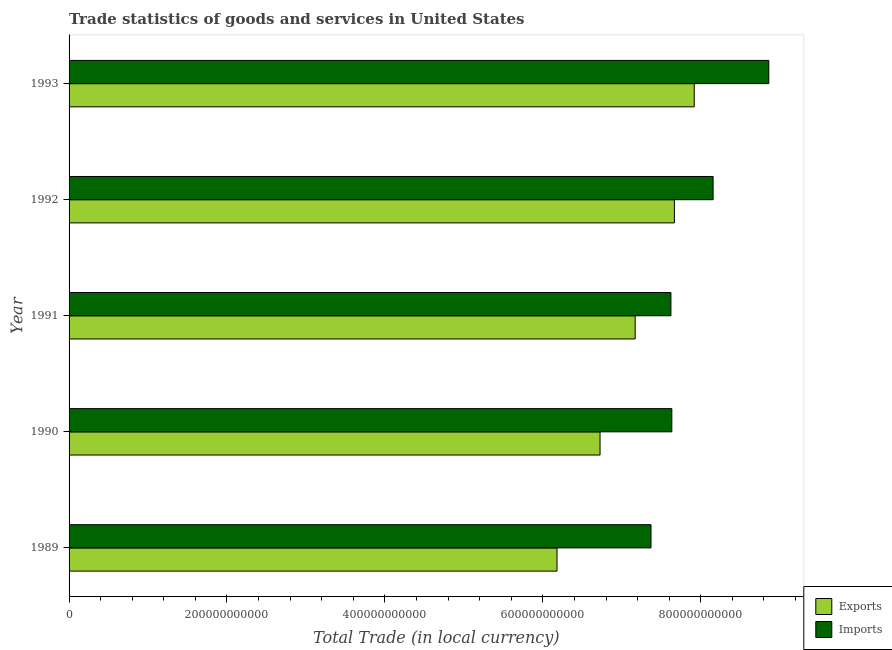How many different coloured bars are there?
Your answer should be very brief. 2. How many bars are there on the 1st tick from the top?
Make the answer very short. 2. How many bars are there on the 5th tick from the bottom?
Offer a terse response. 2. What is the export of goods and services in 1993?
Your answer should be very brief. 7.92e+11. Across all years, what is the maximum imports of goods and services?
Give a very brief answer. 8.86e+11. Across all years, what is the minimum export of goods and services?
Offer a very short reply. 6.18e+11. In which year was the export of goods and services maximum?
Make the answer very short. 1993. What is the total imports of goods and services in the graph?
Provide a short and direct response. 3.96e+12. What is the difference between the imports of goods and services in 1989 and that in 1990?
Ensure brevity in your answer.  -2.64e+1. What is the difference between the export of goods and services in 1989 and the imports of goods and services in 1993?
Ensure brevity in your answer.  -2.68e+11. What is the average export of goods and services per year?
Your answer should be very brief. 7.13e+11. In the year 1989, what is the difference between the export of goods and services and imports of goods and services?
Ensure brevity in your answer.  -1.19e+11. In how many years, is the imports of goods and services greater than 840000000000 LCU?
Offer a very short reply. 1. What is the ratio of the imports of goods and services in 1989 to that in 1991?
Offer a terse response. 0.97. What is the difference between the highest and the second highest imports of goods and services?
Your response must be concise. 7.05e+1. What is the difference between the highest and the lowest imports of goods and services?
Give a very brief answer. 1.49e+11. In how many years, is the export of goods and services greater than the average export of goods and services taken over all years?
Provide a short and direct response. 3. Is the sum of the export of goods and services in 1990 and 1993 greater than the maximum imports of goods and services across all years?
Offer a very short reply. Yes. What does the 1st bar from the top in 1992 represents?
Offer a terse response. Imports. What does the 2nd bar from the bottom in 1989 represents?
Provide a short and direct response. Imports. What is the difference between two consecutive major ticks on the X-axis?
Your response must be concise. 2.00e+11. Where does the legend appear in the graph?
Provide a short and direct response. Bottom right. How many legend labels are there?
Your answer should be very brief. 2. What is the title of the graph?
Offer a terse response. Trade statistics of goods and services in United States. Does "Age 65(male)" appear as one of the legend labels in the graph?
Your answer should be compact. No. What is the label or title of the X-axis?
Offer a terse response. Total Trade (in local currency). What is the Total Trade (in local currency) of Exports in 1989?
Ensure brevity in your answer.  6.18e+11. What is the Total Trade (in local currency) in Imports in 1989?
Offer a terse response. 7.37e+11. What is the Total Trade (in local currency) in Exports in 1990?
Provide a succinct answer. 6.72e+11. What is the Total Trade (in local currency) of Imports in 1990?
Your answer should be very brief. 7.63e+11. What is the Total Trade (in local currency) in Exports in 1991?
Keep it short and to the point. 7.17e+11. What is the Total Trade (in local currency) in Imports in 1991?
Make the answer very short. 7.62e+11. What is the Total Trade (in local currency) of Exports in 1992?
Offer a terse response. 7.67e+11. What is the Total Trade (in local currency) in Imports in 1992?
Offer a terse response. 8.16e+11. What is the Total Trade (in local currency) in Exports in 1993?
Offer a terse response. 7.92e+11. What is the Total Trade (in local currency) of Imports in 1993?
Ensure brevity in your answer.  8.86e+11. Across all years, what is the maximum Total Trade (in local currency) in Exports?
Ensure brevity in your answer.  7.92e+11. Across all years, what is the maximum Total Trade (in local currency) in Imports?
Provide a succinct answer. 8.86e+11. Across all years, what is the minimum Total Trade (in local currency) of Exports?
Provide a succinct answer. 6.18e+11. Across all years, what is the minimum Total Trade (in local currency) in Imports?
Offer a terse response. 7.37e+11. What is the total Total Trade (in local currency) in Exports in the graph?
Your response must be concise. 3.57e+12. What is the total Total Trade (in local currency) of Imports in the graph?
Provide a short and direct response. 3.96e+12. What is the difference between the Total Trade (in local currency) of Exports in 1989 and that in 1990?
Offer a very short reply. -5.45e+1. What is the difference between the Total Trade (in local currency) in Imports in 1989 and that in 1990?
Ensure brevity in your answer.  -2.64e+1. What is the difference between the Total Trade (in local currency) in Exports in 1989 and that in 1991?
Your answer should be compact. -9.90e+1. What is the difference between the Total Trade (in local currency) of Imports in 1989 and that in 1991?
Offer a very short reply. -2.52e+1. What is the difference between the Total Trade (in local currency) of Exports in 1989 and that in 1992?
Make the answer very short. -1.49e+11. What is the difference between the Total Trade (in local currency) of Imports in 1989 and that in 1992?
Offer a terse response. -7.87e+1. What is the difference between the Total Trade (in local currency) of Exports in 1989 and that in 1993?
Keep it short and to the point. -1.74e+11. What is the difference between the Total Trade (in local currency) in Imports in 1989 and that in 1993?
Make the answer very short. -1.49e+11. What is the difference between the Total Trade (in local currency) of Exports in 1990 and that in 1991?
Keep it short and to the point. -4.45e+1. What is the difference between the Total Trade (in local currency) of Imports in 1990 and that in 1991?
Give a very brief answer. 1.14e+09. What is the difference between the Total Trade (in local currency) of Exports in 1990 and that in 1992?
Your answer should be very brief. -9.42e+1. What is the difference between the Total Trade (in local currency) of Imports in 1990 and that in 1992?
Provide a short and direct response. -5.23e+1. What is the difference between the Total Trade (in local currency) in Exports in 1990 and that in 1993?
Provide a succinct answer. -1.19e+11. What is the difference between the Total Trade (in local currency) of Imports in 1990 and that in 1993?
Provide a short and direct response. -1.23e+11. What is the difference between the Total Trade (in local currency) of Exports in 1991 and that in 1992?
Your answer should be very brief. -4.97e+1. What is the difference between the Total Trade (in local currency) in Imports in 1991 and that in 1992?
Offer a terse response. -5.34e+1. What is the difference between the Total Trade (in local currency) in Exports in 1991 and that in 1993?
Offer a very short reply. -7.48e+1. What is the difference between the Total Trade (in local currency) in Imports in 1991 and that in 1993?
Keep it short and to the point. -1.24e+11. What is the difference between the Total Trade (in local currency) of Exports in 1992 and that in 1993?
Provide a succinct answer. -2.51e+1. What is the difference between the Total Trade (in local currency) in Imports in 1992 and that in 1993?
Your answer should be very brief. -7.05e+1. What is the difference between the Total Trade (in local currency) of Exports in 1989 and the Total Trade (in local currency) of Imports in 1990?
Your answer should be very brief. -1.45e+11. What is the difference between the Total Trade (in local currency) in Exports in 1989 and the Total Trade (in local currency) in Imports in 1991?
Offer a very short reply. -1.44e+11. What is the difference between the Total Trade (in local currency) of Exports in 1989 and the Total Trade (in local currency) of Imports in 1992?
Offer a very short reply. -1.98e+11. What is the difference between the Total Trade (in local currency) of Exports in 1989 and the Total Trade (in local currency) of Imports in 1993?
Keep it short and to the point. -2.68e+11. What is the difference between the Total Trade (in local currency) of Exports in 1990 and the Total Trade (in local currency) of Imports in 1991?
Keep it short and to the point. -8.98e+1. What is the difference between the Total Trade (in local currency) of Exports in 1990 and the Total Trade (in local currency) of Imports in 1992?
Ensure brevity in your answer.  -1.43e+11. What is the difference between the Total Trade (in local currency) of Exports in 1990 and the Total Trade (in local currency) of Imports in 1993?
Your answer should be compact. -2.14e+11. What is the difference between the Total Trade (in local currency) in Exports in 1991 and the Total Trade (in local currency) in Imports in 1992?
Give a very brief answer. -9.87e+1. What is the difference between the Total Trade (in local currency) in Exports in 1991 and the Total Trade (in local currency) in Imports in 1993?
Make the answer very short. -1.69e+11. What is the difference between the Total Trade (in local currency) in Exports in 1992 and the Total Trade (in local currency) in Imports in 1993?
Keep it short and to the point. -1.20e+11. What is the average Total Trade (in local currency) of Exports per year?
Give a very brief answer. 7.13e+11. What is the average Total Trade (in local currency) of Imports per year?
Your answer should be very brief. 7.93e+11. In the year 1989, what is the difference between the Total Trade (in local currency) in Exports and Total Trade (in local currency) in Imports?
Your response must be concise. -1.19e+11. In the year 1990, what is the difference between the Total Trade (in local currency) in Exports and Total Trade (in local currency) in Imports?
Provide a succinct answer. -9.09e+1. In the year 1991, what is the difference between the Total Trade (in local currency) of Exports and Total Trade (in local currency) of Imports?
Offer a very short reply. -4.53e+1. In the year 1992, what is the difference between the Total Trade (in local currency) of Exports and Total Trade (in local currency) of Imports?
Your response must be concise. -4.90e+1. In the year 1993, what is the difference between the Total Trade (in local currency) in Exports and Total Trade (in local currency) in Imports?
Provide a succinct answer. -9.44e+1. What is the ratio of the Total Trade (in local currency) of Exports in 1989 to that in 1990?
Provide a short and direct response. 0.92. What is the ratio of the Total Trade (in local currency) of Imports in 1989 to that in 1990?
Provide a short and direct response. 0.97. What is the ratio of the Total Trade (in local currency) in Exports in 1989 to that in 1991?
Give a very brief answer. 0.86. What is the ratio of the Total Trade (in local currency) of Imports in 1989 to that in 1991?
Keep it short and to the point. 0.97. What is the ratio of the Total Trade (in local currency) of Exports in 1989 to that in 1992?
Give a very brief answer. 0.81. What is the ratio of the Total Trade (in local currency) in Imports in 1989 to that in 1992?
Your answer should be very brief. 0.9. What is the ratio of the Total Trade (in local currency) in Exports in 1989 to that in 1993?
Ensure brevity in your answer.  0.78. What is the ratio of the Total Trade (in local currency) in Imports in 1989 to that in 1993?
Your response must be concise. 0.83. What is the ratio of the Total Trade (in local currency) of Exports in 1990 to that in 1991?
Make the answer very short. 0.94. What is the ratio of the Total Trade (in local currency) in Imports in 1990 to that in 1991?
Offer a very short reply. 1. What is the ratio of the Total Trade (in local currency) of Exports in 1990 to that in 1992?
Your answer should be compact. 0.88. What is the ratio of the Total Trade (in local currency) in Imports in 1990 to that in 1992?
Ensure brevity in your answer.  0.94. What is the ratio of the Total Trade (in local currency) of Exports in 1990 to that in 1993?
Offer a very short reply. 0.85. What is the ratio of the Total Trade (in local currency) of Imports in 1990 to that in 1993?
Offer a terse response. 0.86. What is the ratio of the Total Trade (in local currency) of Exports in 1991 to that in 1992?
Ensure brevity in your answer.  0.94. What is the ratio of the Total Trade (in local currency) in Imports in 1991 to that in 1992?
Your answer should be compact. 0.93. What is the ratio of the Total Trade (in local currency) in Exports in 1991 to that in 1993?
Give a very brief answer. 0.91. What is the ratio of the Total Trade (in local currency) in Imports in 1991 to that in 1993?
Offer a very short reply. 0.86. What is the ratio of the Total Trade (in local currency) in Exports in 1992 to that in 1993?
Offer a very short reply. 0.97. What is the ratio of the Total Trade (in local currency) in Imports in 1992 to that in 1993?
Make the answer very short. 0.92. What is the difference between the highest and the second highest Total Trade (in local currency) in Exports?
Keep it short and to the point. 2.51e+1. What is the difference between the highest and the second highest Total Trade (in local currency) of Imports?
Offer a very short reply. 7.05e+1. What is the difference between the highest and the lowest Total Trade (in local currency) of Exports?
Ensure brevity in your answer.  1.74e+11. What is the difference between the highest and the lowest Total Trade (in local currency) of Imports?
Offer a terse response. 1.49e+11. 